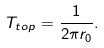Convert formula to latex. <formula><loc_0><loc_0><loc_500><loc_500>T _ { t o p } = \frac { 1 } { 2 \pi r _ { 0 } } .</formula> 